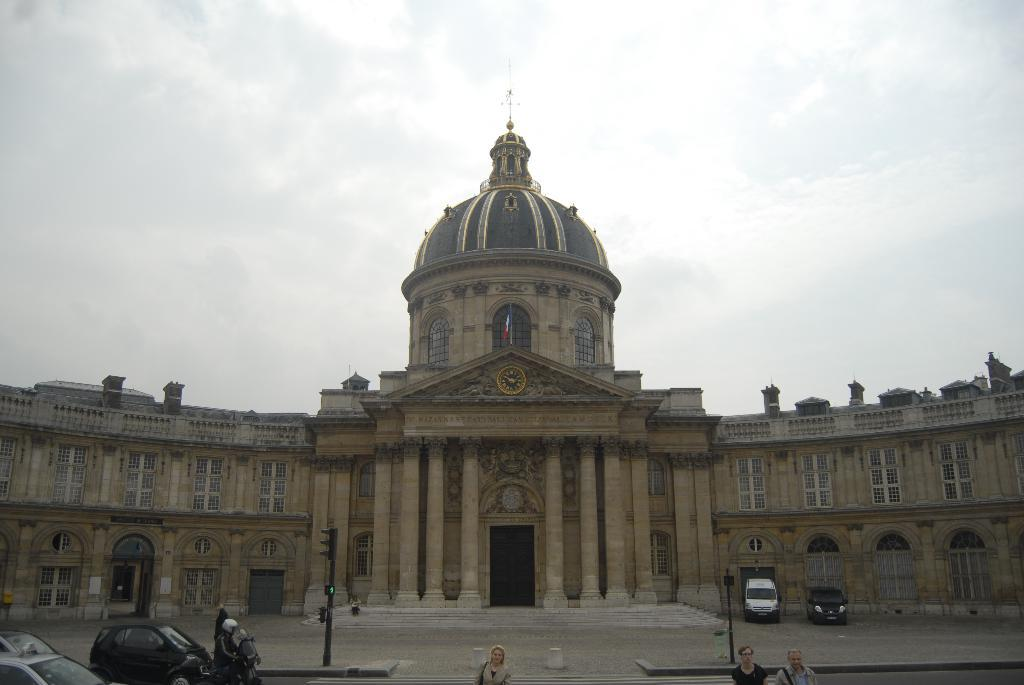What type of structure is visible in the image? There is a building in the image. What features can be seen on the building? The building has windows, doors, and stairs. What else is visible in the image besides the building? There are vehicles on the road, poles, people, and the sky is visible at the top of the image. What type of drum can be seen being played by a person in the image? There is no drum present in the image; it only features a building, vehicles, poles, people, and the sky. What kind of soap is being used by the people in the image? There is no soap visible in the image; it only features a building, vehicles, poles, people, and the sky. 